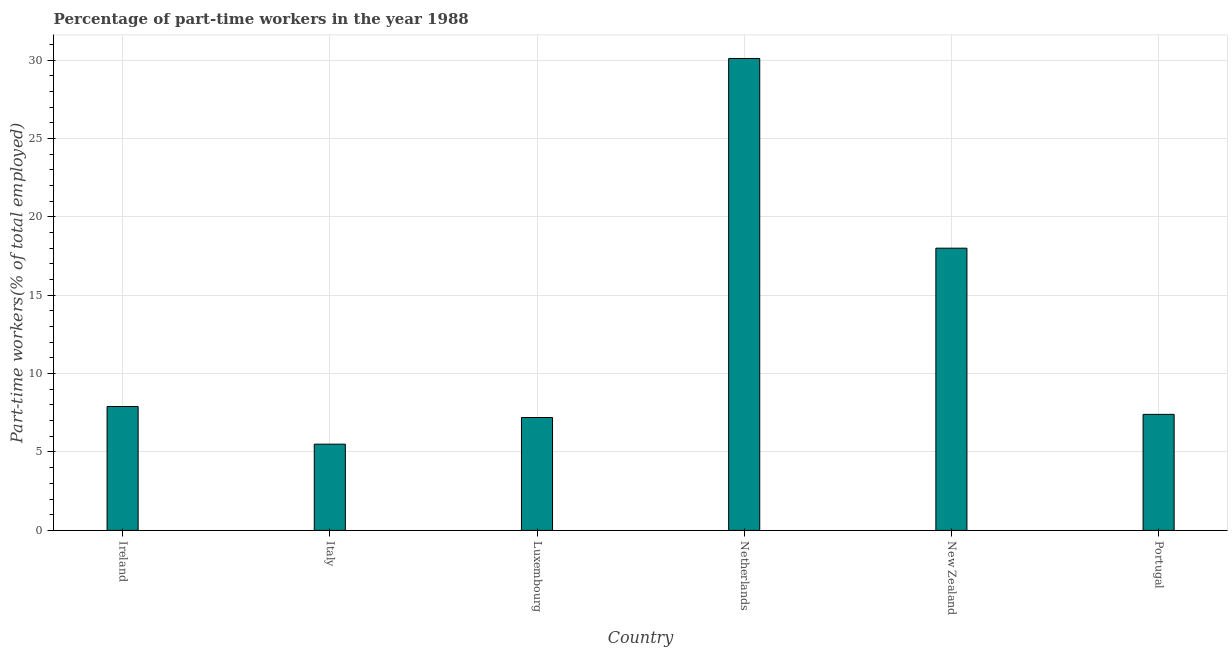Does the graph contain any zero values?
Your answer should be compact. No. Does the graph contain grids?
Your response must be concise. Yes. What is the title of the graph?
Keep it short and to the point. Percentage of part-time workers in the year 1988. What is the label or title of the Y-axis?
Your response must be concise. Part-time workers(% of total employed). Across all countries, what is the maximum percentage of part-time workers?
Your answer should be very brief. 30.1. Across all countries, what is the minimum percentage of part-time workers?
Your answer should be very brief. 5.5. What is the sum of the percentage of part-time workers?
Make the answer very short. 76.1. What is the average percentage of part-time workers per country?
Provide a short and direct response. 12.68. What is the median percentage of part-time workers?
Give a very brief answer. 7.65. In how many countries, is the percentage of part-time workers greater than 15 %?
Offer a terse response. 2. What is the ratio of the percentage of part-time workers in Ireland to that in Luxembourg?
Keep it short and to the point. 1.1. Is the percentage of part-time workers in Ireland less than that in New Zealand?
Offer a terse response. Yes. Is the difference between the percentage of part-time workers in Ireland and New Zealand greater than the difference between any two countries?
Keep it short and to the point. No. What is the difference between the highest and the second highest percentage of part-time workers?
Provide a succinct answer. 12.1. Is the sum of the percentage of part-time workers in Netherlands and New Zealand greater than the maximum percentage of part-time workers across all countries?
Make the answer very short. Yes. What is the difference between the highest and the lowest percentage of part-time workers?
Give a very brief answer. 24.6. In how many countries, is the percentage of part-time workers greater than the average percentage of part-time workers taken over all countries?
Ensure brevity in your answer.  2. How many countries are there in the graph?
Offer a very short reply. 6. What is the difference between two consecutive major ticks on the Y-axis?
Provide a short and direct response. 5. Are the values on the major ticks of Y-axis written in scientific E-notation?
Your answer should be very brief. No. What is the Part-time workers(% of total employed) in Ireland?
Your answer should be compact. 7.9. What is the Part-time workers(% of total employed) in Luxembourg?
Make the answer very short. 7.2. What is the Part-time workers(% of total employed) of Netherlands?
Make the answer very short. 30.1. What is the Part-time workers(% of total employed) of Portugal?
Make the answer very short. 7.4. What is the difference between the Part-time workers(% of total employed) in Ireland and Luxembourg?
Give a very brief answer. 0.7. What is the difference between the Part-time workers(% of total employed) in Ireland and Netherlands?
Your response must be concise. -22.2. What is the difference between the Part-time workers(% of total employed) in Italy and Luxembourg?
Make the answer very short. -1.7. What is the difference between the Part-time workers(% of total employed) in Italy and Netherlands?
Keep it short and to the point. -24.6. What is the difference between the Part-time workers(% of total employed) in Italy and New Zealand?
Your answer should be compact. -12.5. What is the difference between the Part-time workers(% of total employed) in Italy and Portugal?
Provide a short and direct response. -1.9. What is the difference between the Part-time workers(% of total employed) in Luxembourg and Netherlands?
Your answer should be very brief. -22.9. What is the difference between the Part-time workers(% of total employed) in Luxembourg and Portugal?
Your response must be concise. -0.2. What is the difference between the Part-time workers(% of total employed) in Netherlands and New Zealand?
Your response must be concise. 12.1. What is the difference between the Part-time workers(% of total employed) in Netherlands and Portugal?
Make the answer very short. 22.7. What is the difference between the Part-time workers(% of total employed) in New Zealand and Portugal?
Provide a succinct answer. 10.6. What is the ratio of the Part-time workers(% of total employed) in Ireland to that in Italy?
Make the answer very short. 1.44. What is the ratio of the Part-time workers(% of total employed) in Ireland to that in Luxembourg?
Your response must be concise. 1.1. What is the ratio of the Part-time workers(% of total employed) in Ireland to that in Netherlands?
Offer a very short reply. 0.26. What is the ratio of the Part-time workers(% of total employed) in Ireland to that in New Zealand?
Provide a short and direct response. 0.44. What is the ratio of the Part-time workers(% of total employed) in Ireland to that in Portugal?
Ensure brevity in your answer.  1.07. What is the ratio of the Part-time workers(% of total employed) in Italy to that in Luxembourg?
Offer a very short reply. 0.76. What is the ratio of the Part-time workers(% of total employed) in Italy to that in Netherlands?
Provide a succinct answer. 0.18. What is the ratio of the Part-time workers(% of total employed) in Italy to that in New Zealand?
Give a very brief answer. 0.31. What is the ratio of the Part-time workers(% of total employed) in Italy to that in Portugal?
Your answer should be compact. 0.74. What is the ratio of the Part-time workers(% of total employed) in Luxembourg to that in Netherlands?
Give a very brief answer. 0.24. What is the ratio of the Part-time workers(% of total employed) in Luxembourg to that in Portugal?
Your answer should be very brief. 0.97. What is the ratio of the Part-time workers(% of total employed) in Netherlands to that in New Zealand?
Keep it short and to the point. 1.67. What is the ratio of the Part-time workers(% of total employed) in Netherlands to that in Portugal?
Give a very brief answer. 4.07. What is the ratio of the Part-time workers(% of total employed) in New Zealand to that in Portugal?
Ensure brevity in your answer.  2.43. 